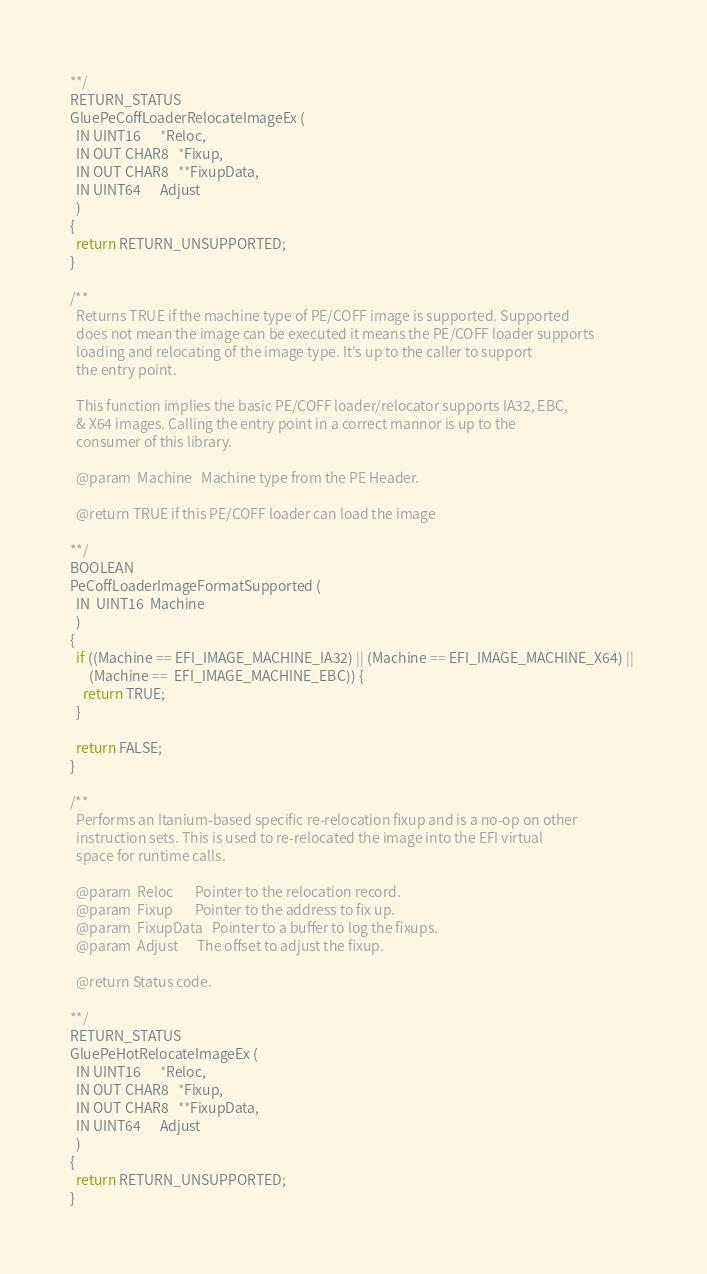Convert code to text. <code><loc_0><loc_0><loc_500><loc_500><_C_>**/
RETURN_STATUS
GluePeCoffLoaderRelocateImageEx (
  IN UINT16      *Reloc,
  IN OUT CHAR8   *Fixup,
  IN OUT CHAR8   **FixupData,
  IN UINT64      Adjust
  )
{
  return RETURN_UNSUPPORTED;
}

/**
  Returns TRUE if the machine type of PE/COFF image is supported. Supported 
  does not mean the image can be executed it means the PE/COFF loader supports
  loading and relocating of the image type. It's up to the caller to support
  the entry point. 

  This function implies the basic PE/COFF loader/relocator supports IA32, EBC,
  & X64 images. Calling the entry point in a correct mannor is up to the 
  consumer of this library.

  @param  Machine   Machine type from the PE Header.

  @return TRUE if this PE/COFF loader can load the image

**/
BOOLEAN
PeCoffLoaderImageFormatSupported (
  IN  UINT16  Machine
  )
{
  if ((Machine == EFI_IMAGE_MACHINE_IA32) || (Machine == EFI_IMAGE_MACHINE_X64) || 
      (Machine ==  EFI_IMAGE_MACHINE_EBC)) {
    return TRUE; 
  }

  return FALSE;
}

/**
  Performs an Itanium-based specific re-relocation fixup and is a no-op on other
  instruction sets. This is used to re-relocated the image into the EFI virtual
  space for runtime calls.

  @param  Reloc       Pointer to the relocation record.
  @param  Fixup       Pointer to the address to fix up.
  @param  FixupData   Pointer to a buffer to log the fixups.
  @param  Adjust      The offset to adjust the fixup.

  @return Status code.

**/
RETURN_STATUS
GluePeHotRelocateImageEx (
  IN UINT16      *Reloc,
  IN OUT CHAR8   *Fixup,
  IN OUT CHAR8   **FixupData,
  IN UINT64      Adjust
  )
{
  return RETURN_UNSUPPORTED;
}

</code> 